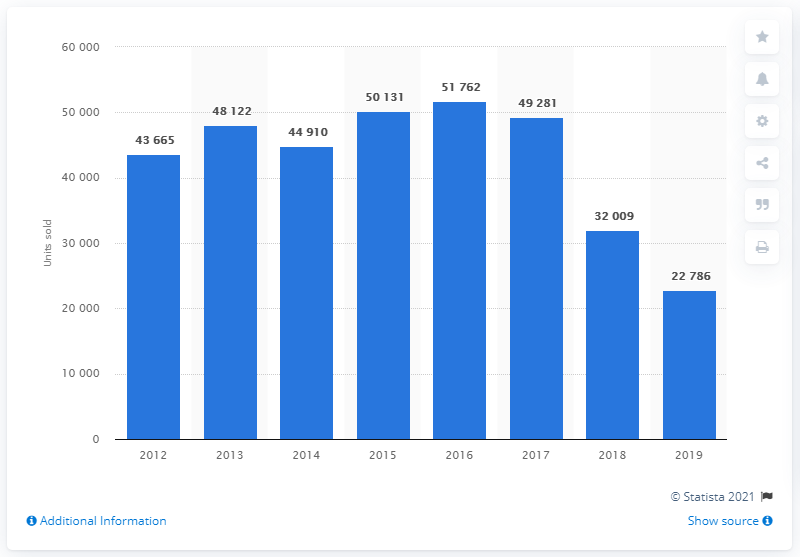Point out several critical features in this image. In 2016, a record-breaking 51,762 Hyundai cars were sold in Turkey, solidifying the brand's position as a leading player in the Turkish automotive market. In 2019, Hyundai sold a total of 22,786 cars in Turkey. 